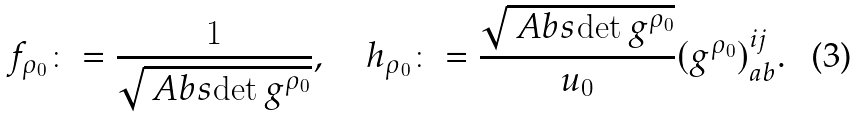Convert formula to latex. <formula><loc_0><loc_0><loc_500><loc_500>f _ { \rho _ { 0 } } \colon = \frac { 1 } { \sqrt { \ A b s { \det g ^ { \rho _ { 0 } } } } } , \quad h _ { \rho _ { 0 } } \colon = \frac { \sqrt { \ A b s { \det g ^ { \rho _ { 0 } } } } } { u _ { 0 } } ( g ^ { \rho _ { 0 } } ) ^ { i j } _ { a b } .</formula> 